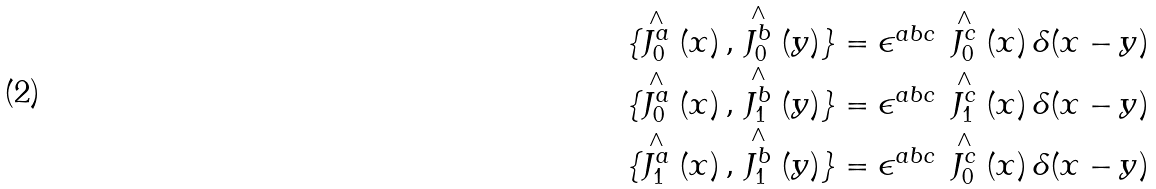<formula> <loc_0><loc_0><loc_500><loc_500>\begin{array} { c } \{ \stackrel { \wedge } { J ^ { a } _ { 0 } } ( x ) \, , \, \stackrel { \wedge } { J ^ { b } _ { 0 } } ( y ) \} = \epsilon ^ { a b c } \, \stackrel { \wedge } { J ^ { c } _ { 0 } } ( x ) \, \delta ( x - y ) \\ \{ \stackrel { \wedge } { J ^ { a } _ { 0 } } ( x ) \, , \, \stackrel { \wedge } { J ^ { b } _ { 1 } } ( y ) \} = \epsilon ^ { a b c } \, \stackrel { \wedge } { J ^ { c } _ { 1 } } ( x ) \, \delta ( x - y ) \\ \{ \stackrel { \wedge } { J ^ { a } _ { 1 } } ( x ) \, , \, \stackrel { \wedge } { J ^ { b } _ { 1 } } ( y ) \} = \epsilon ^ { a b c } \, \stackrel { \wedge } { J ^ { c } _ { 0 } } ( x ) \, \delta ( x - y ) \\ \end{array}</formula> 